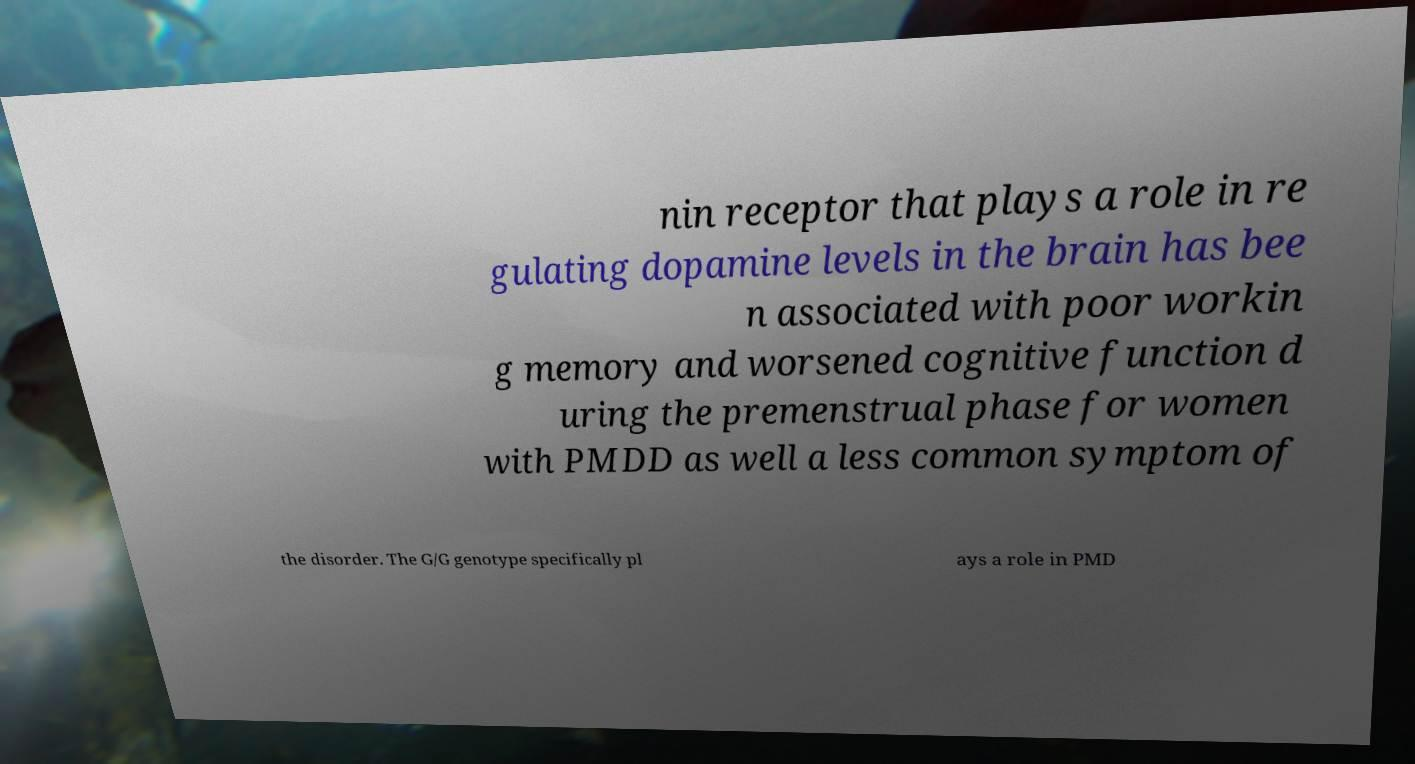What messages or text are displayed in this image? I need them in a readable, typed format. nin receptor that plays a role in re gulating dopamine levels in the brain has bee n associated with poor workin g memory and worsened cognitive function d uring the premenstrual phase for women with PMDD as well a less common symptom of the disorder. The G/G genotype specifically pl ays a role in PMD 